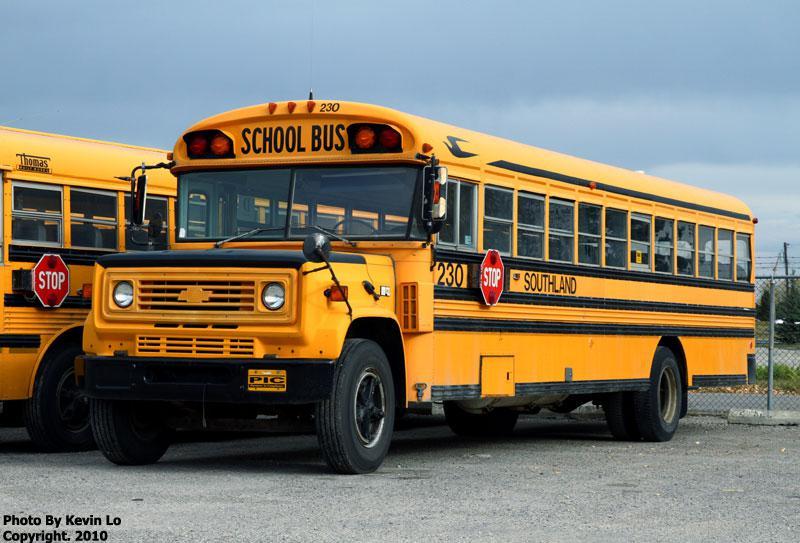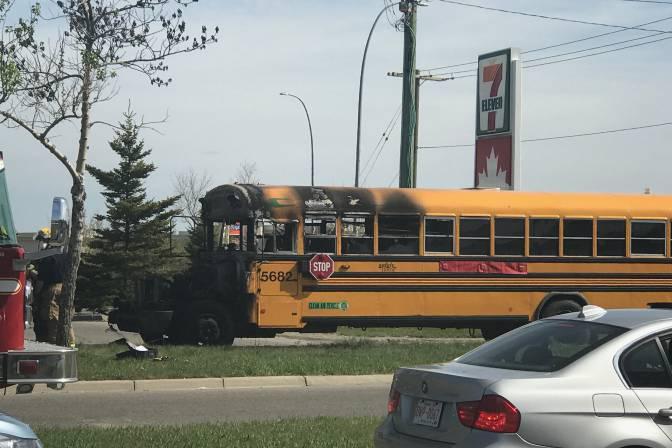The first image is the image on the left, the second image is the image on the right. Examine the images to the left and right. Is the description "One of the images shows a school bus that has had an accident." accurate? Answer yes or no. Yes. 